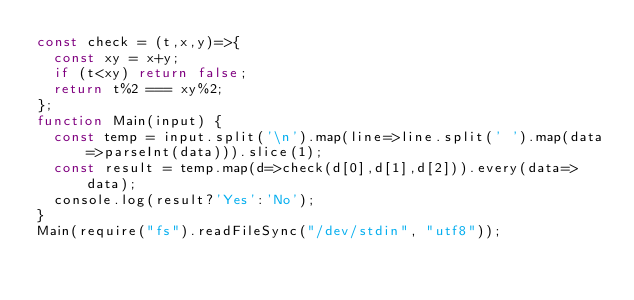Convert code to text. <code><loc_0><loc_0><loc_500><loc_500><_JavaScript_>const check = (t,x,y)=>{
  const xy = x+y;
  if (t<xy) return false;
  return t%2 === xy%2;
};
function Main(input) {
  const temp = input.split('\n').map(line=>line.split(' ').map(data=>parseInt(data))).slice(1);
  const result = temp.map(d=>check(d[0],d[1],d[2])).every(data=>data);
  console.log(result?'Yes':'No');
}
Main(require("fs").readFileSync("/dev/stdin", "utf8"));</code> 